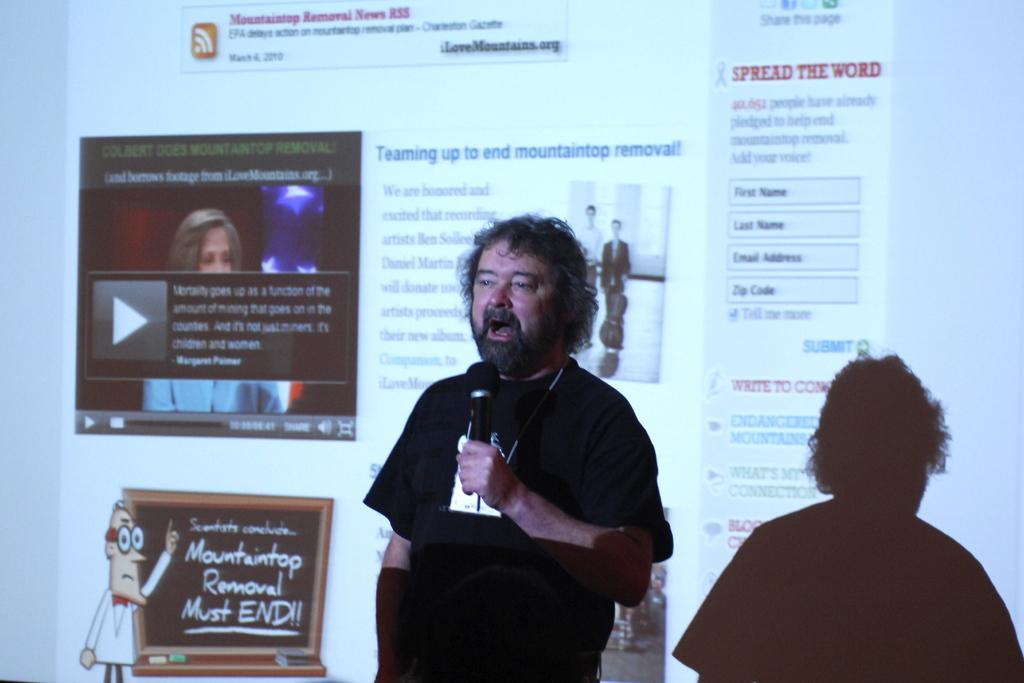Describe this image in one or two sentences. This picture shows a man standing and speaking with the help of a microphone and we see a projector screen on his back 